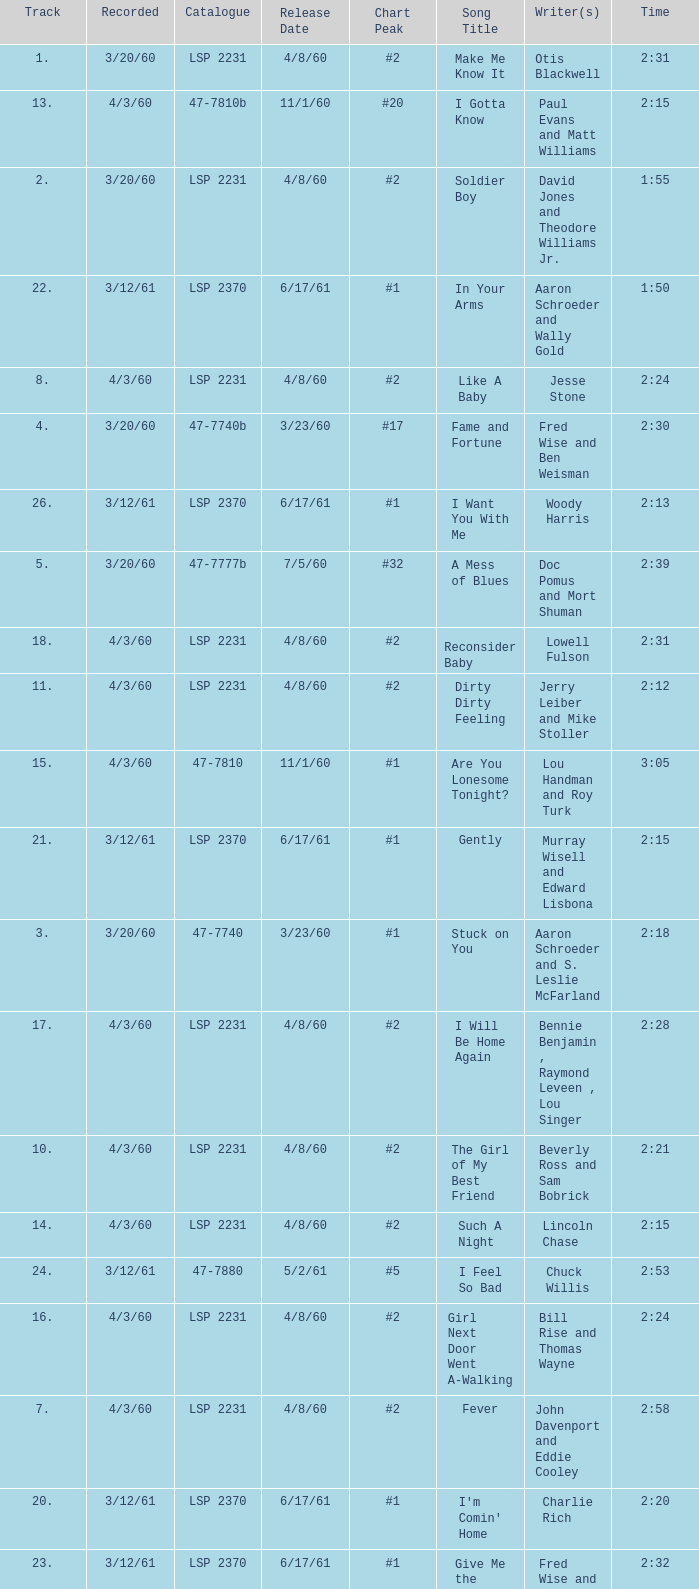On songs that have a release date of 6/17/61, a track larger than 20, and a writer of Woody Harris, what is the chart peak? #1. 